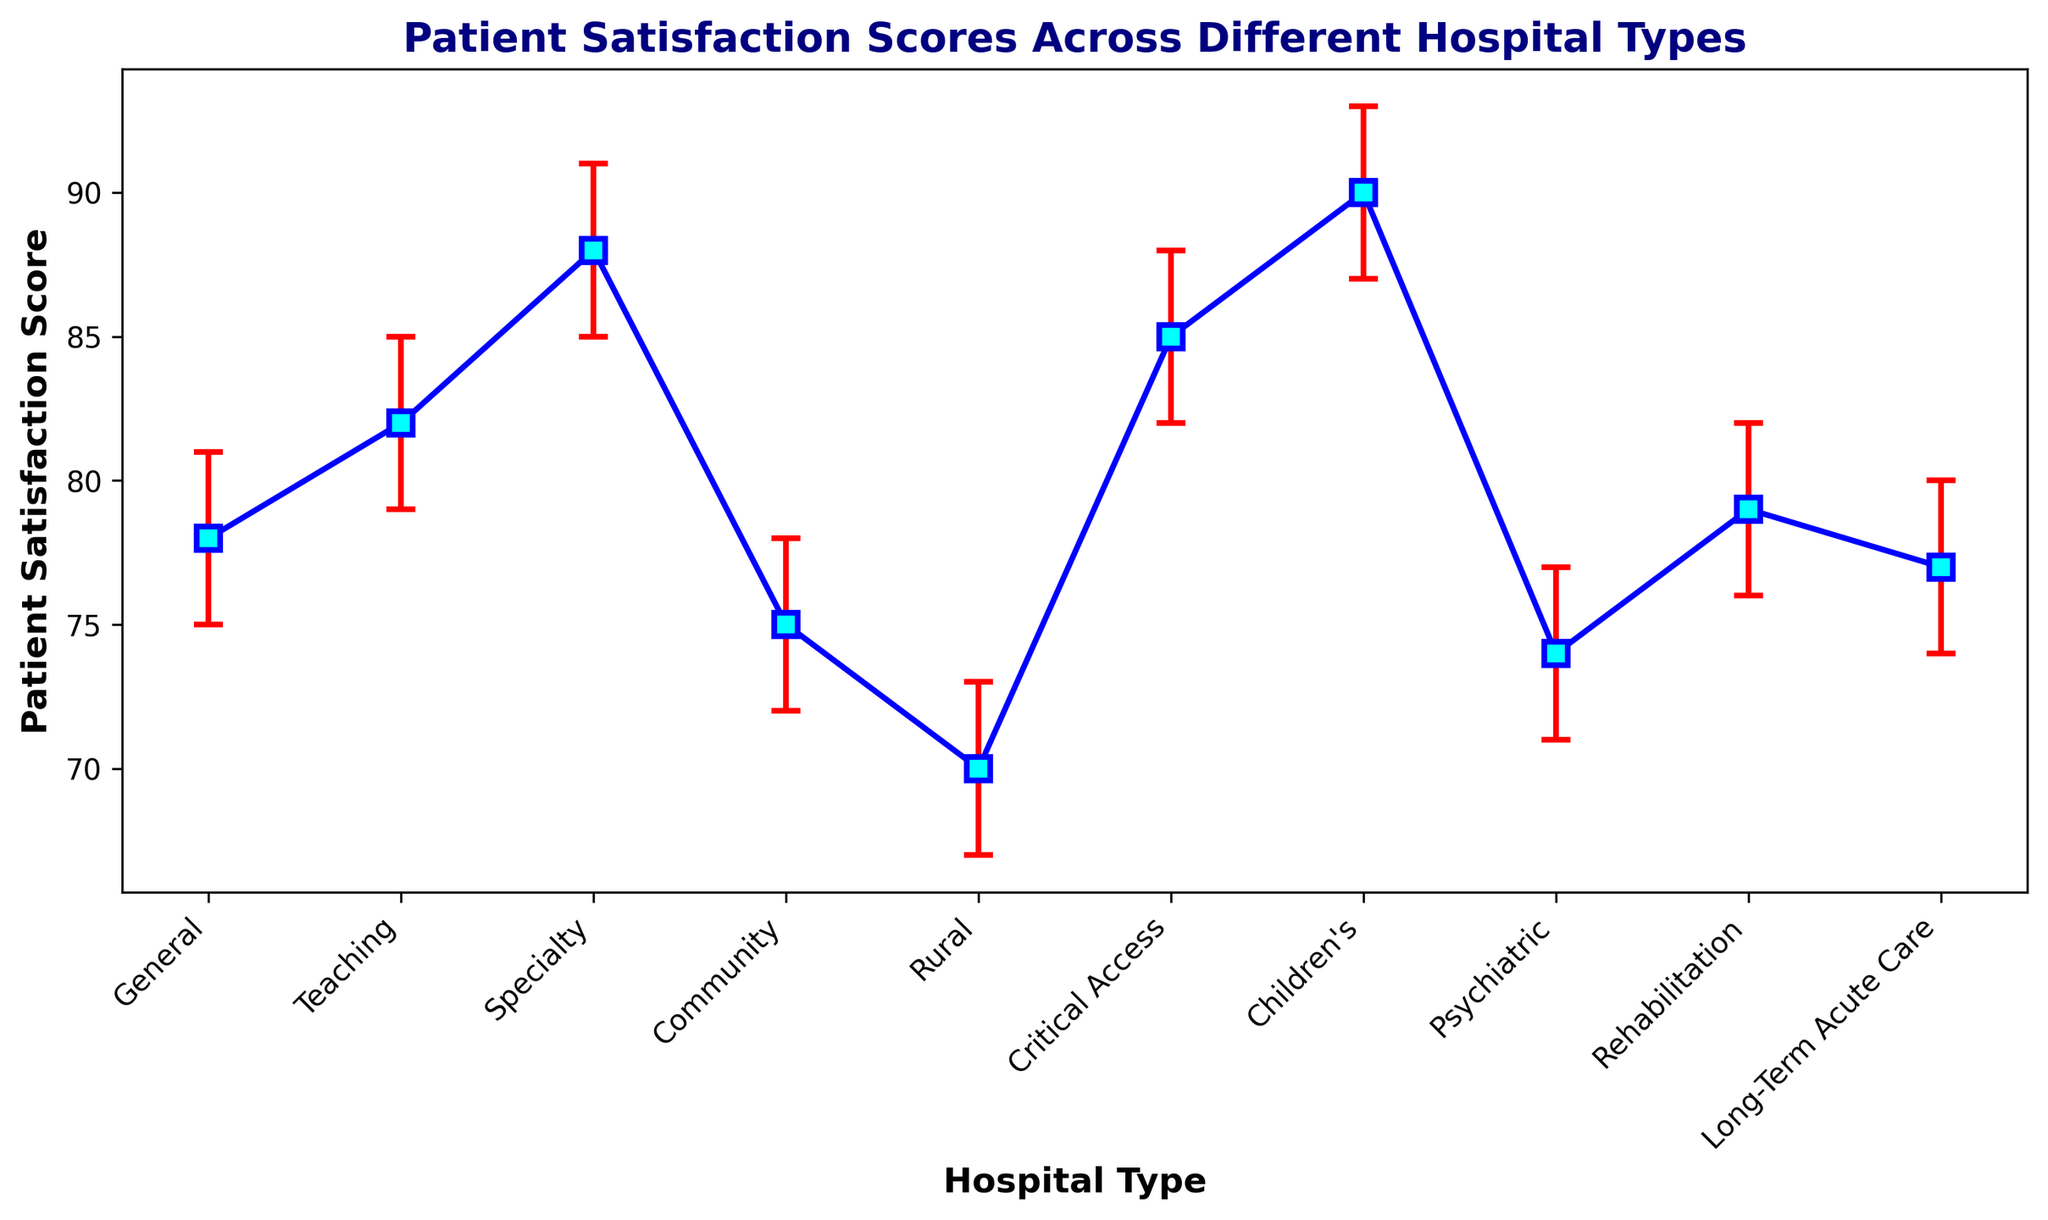What is the highest patient satisfaction score among the hospital types? The highest patient satisfaction score can be found by looking for the highest data point on the plot. The plot indicates that the Children's hospital type has the highest score of 90.
Answer: Children's (90) Which hospital type has the largest confidence interval range? To determine the largest confidence interval range, calculate the difference between the upper and lower bounds of the confidence interval for each hospital type. The largest range is 6 (93-87) for Children's hospital type.
Answer: Children's What is the difference in patient satisfaction scores between Rural and Specialty hospitals? Subtract the patient satisfaction score of Rural (70) from Specialty (88). The difference is 88 - 70 = 18.
Answer: 18 Between Teaching and Critical Access hospitals, which has a higher patient satisfaction score? By comparing the patient satisfaction scores from the plot, Teaching hospitals have a score of 82, while Critical Access hospitals have a score of 85. Thus, Critical Access hospitals have a higher score.
Answer: Critical Access What is the average patient satisfaction score for Community and Rehabilitation hospitals? Calculate the average of the scores for Community (75) and Rehabilitation (79). The sum is 75 + 79 = 154, and the average is 154 / 2 = 77.
Answer: 77 How do the error bars for General and Long-Term Acute Care hospitals compare? To compare, observe the lengths of the error bars. Both General and Long-Term Acute Care hospitals have an error bar extending by ±3 from their scores, indicating equal error bars.
Answer: Equal What is the sum of patient satisfaction scores for General, Teaching, and Specialty hospitals? Add the patient satisfaction scores for General (78), Teaching (82), and Specialty (88). The sum is 78 + 82 + 88 = 248.
Answer: 248 Which hospital type has the smallest patient satisfaction score and what is it? By observing the plot, the hospital type with the smallest score is Rural, with a score of 70.
Answer: Rural (70) Between Psychiatric and General hospitals, which one has the more consistent patient satisfaction score based on confidence intervals? More consistent scores have smaller confidence intervals. Psychiatric hospitals have an interval of 6 (77-71), while General hospitals have an interval of 6 (81-75), showing both are equal.
Answer: Equal 